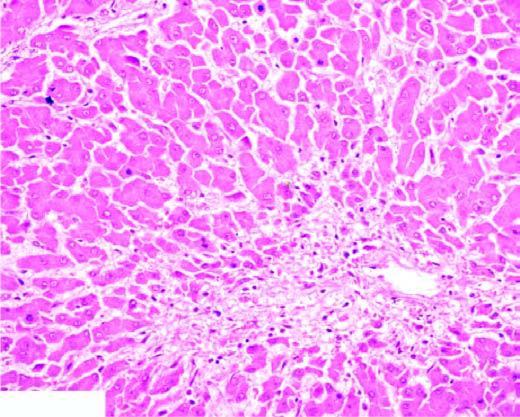what shows marked degeneration and necrosis of hepatocytes accompanied by haemorrhage while the peripheral zone shows mild fatty change of liver cells?
Answer the question using a single word or phrase. Centrilobular cells 